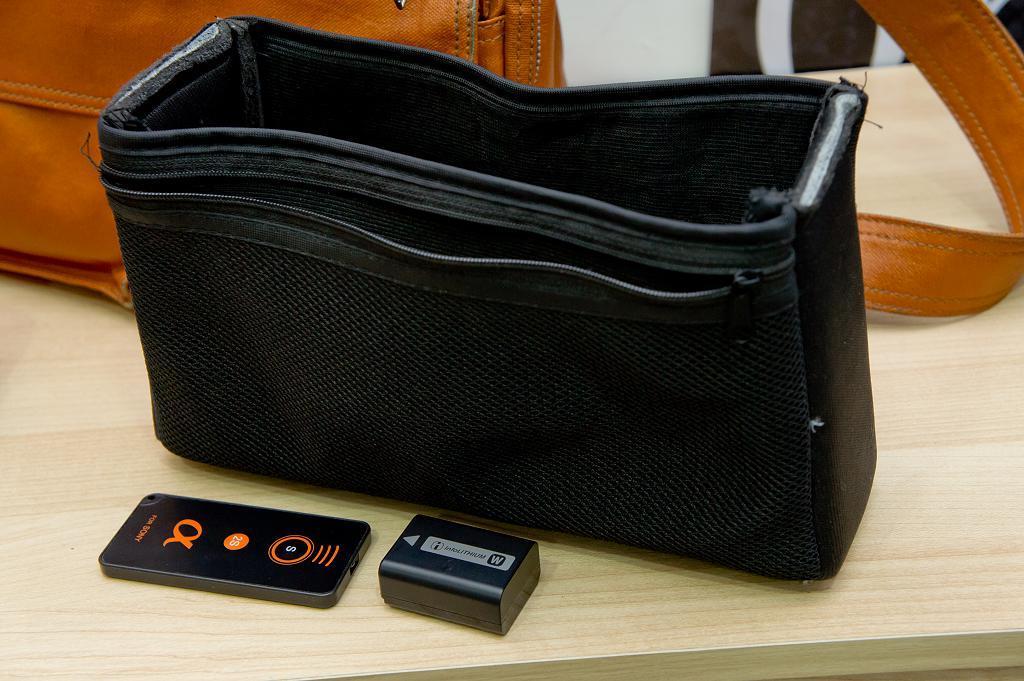Can you describe this image briefly? In the center there is a table,on table there is a bag,ipod,connector and handbag which is in orange color. 